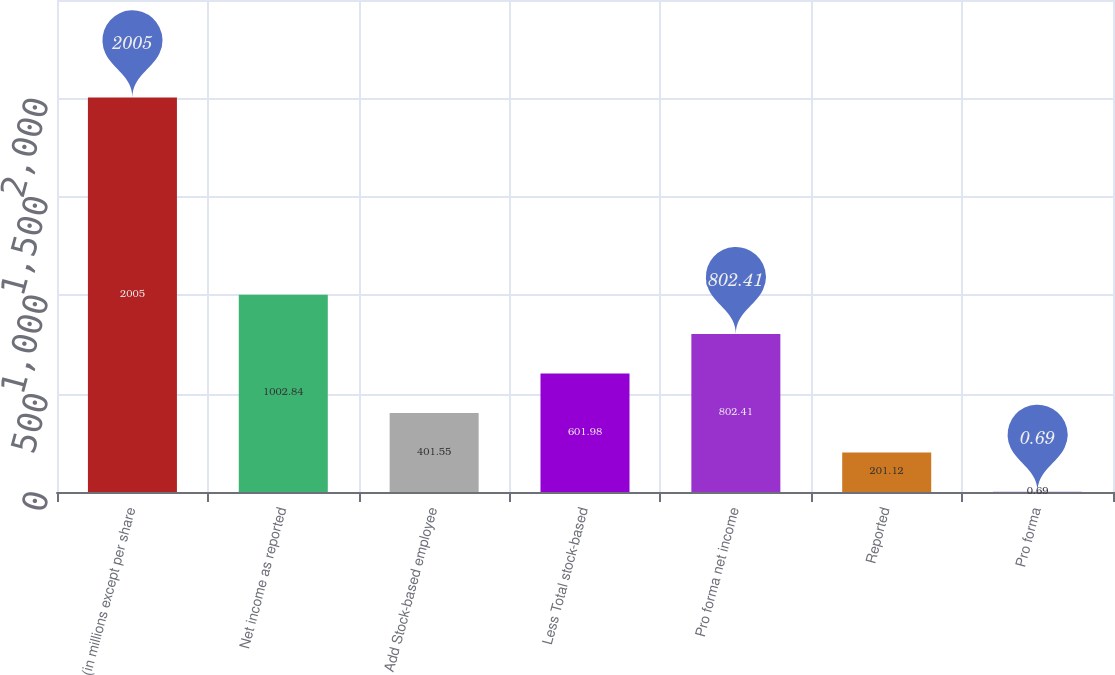Convert chart. <chart><loc_0><loc_0><loc_500><loc_500><bar_chart><fcel>(in millions except per share<fcel>Net income as reported<fcel>Add Stock-based employee<fcel>Less Total stock-based<fcel>Pro forma net income<fcel>Reported<fcel>Pro forma<nl><fcel>2005<fcel>1002.84<fcel>401.55<fcel>601.98<fcel>802.41<fcel>201.12<fcel>0.69<nl></chart> 